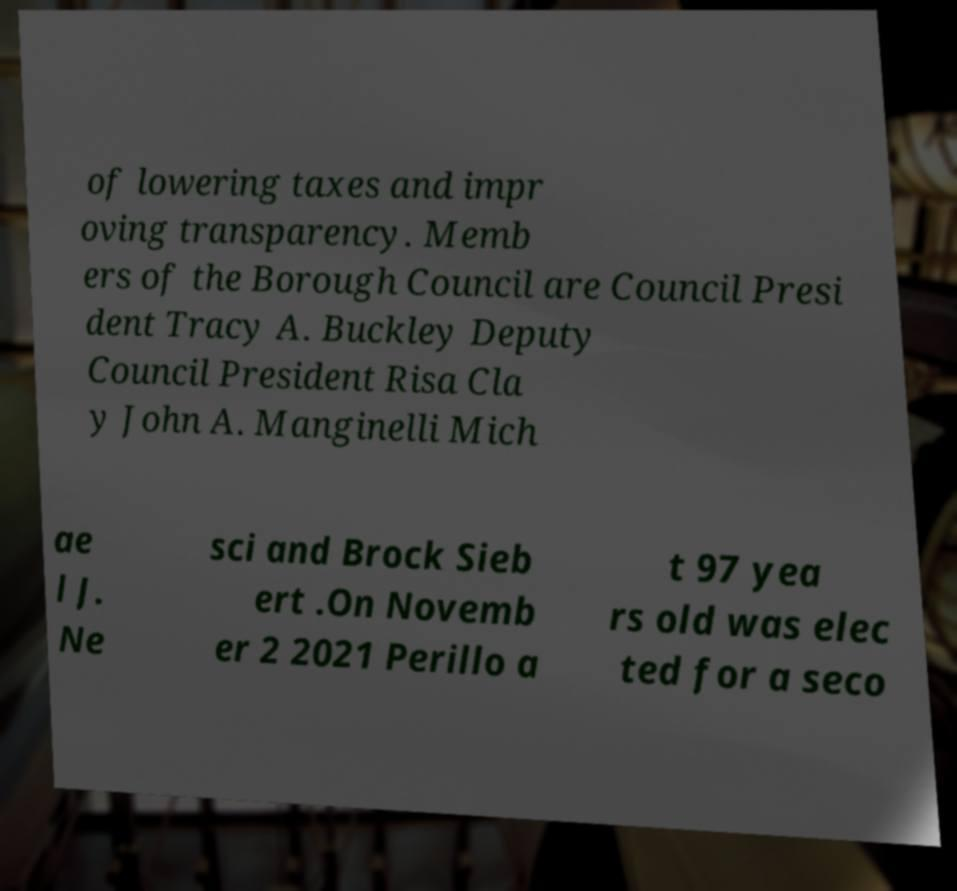Could you extract and type out the text from this image? of lowering taxes and impr oving transparency. Memb ers of the Borough Council are Council Presi dent Tracy A. Buckley Deputy Council President Risa Cla y John A. Manginelli Mich ae l J. Ne sci and Brock Sieb ert .On Novemb er 2 2021 Perillo a t 97 yea rs old was elec ted for a seco 